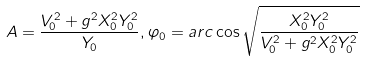<formula> <loc_0><loc_0><loc_500><loc_500>A = \frac { V _ { 0 } ^ { 2 } + g ^ { 2 } X _ { 0 } ^ { 2 } Y _ { 0 } ^ { 2 } } { Y _ { 0 } } , \varphi _ { 0 } = a r c \cos \sqrt { \frac { X _ { 0 } ^ { 2 } Y _ { 0 } ^ { 2 } } { V _ { 0 } ^ { 2 } + g ^ { 2 } X _ { 0 } ^ { 2 } Y _ { 0 } ^ { 2 } } }</formula> 